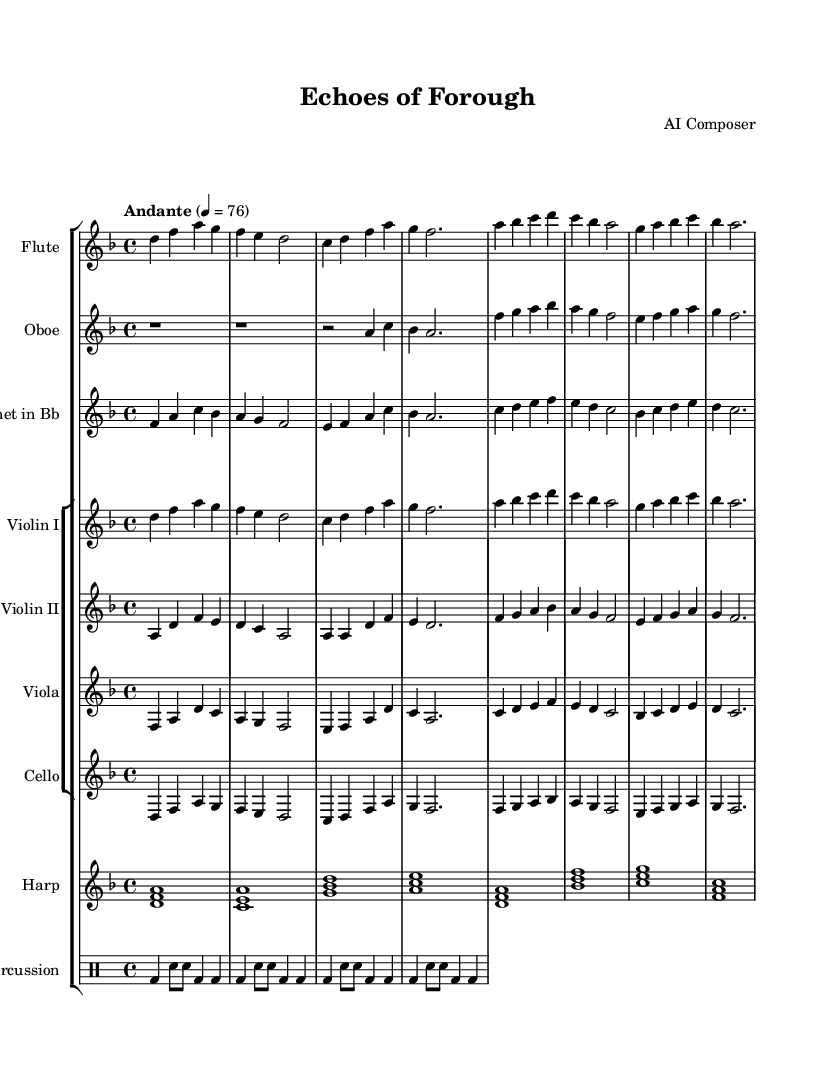What is the key signature of this music? The key signature indicated at the beginning of the score is D minor, which contains one flat (B flat).
Answer: D minor What is the time signature of the composition? The time signature shown in the score is 4/4, which means there are four beats per measure.
Answer: 4/4 What is the tempo marking for this piece? The tempo marking is “Andante,” which generally means a moderate walking pace. It's indicated with a metronome marking of 76 beats per minute.
Answer: Andante, 76 Which instruments are included in this orchestration? The score features a flute, oboe, clarinet, two violins, viola, cello, harp, and percussion. The parts are clearly labeled at the start of each staff.
Answer: Flute, Oboe, Clarinet, Violin I, Violin II, Viola, Cello, Harp, Percussion What roles do the percussion play in this piece? The percussion part consists of a bass drum and snare drum in a consistent rhythm, providing a rhythmic foundation through repeated patterns.
Answer: Rhythmic foundation What is the relationship between the strings' melody and woodwinds' melody in the first few measures? The strings and woodwinds are playing complementary melodies, where the woodwinds often echo or respond to the motifs introduced by the strings, creating a cohesive harmonic texture.
Answer: Complementary melodies 